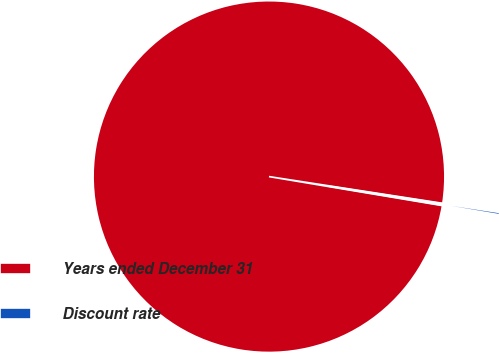<chart> <loc_0><loc_0><loc_500><loc_500><pie_chart><fcel>Years ended December 31<fcel>Discount rate<nl><fcel>99.79%<fcel>0.21%<nl></chart> 